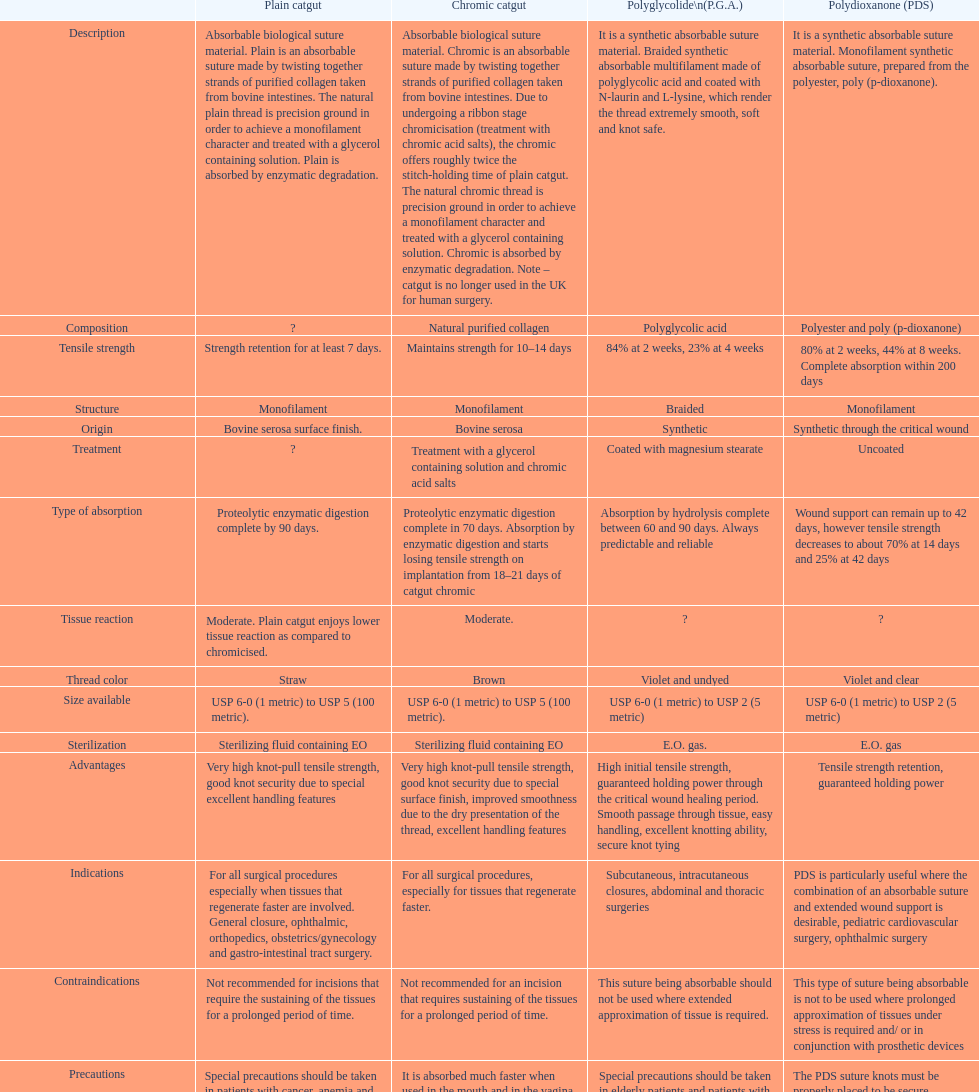In terms of structure, what do plain catgut and chromic catgut have in common? Monofilament. 